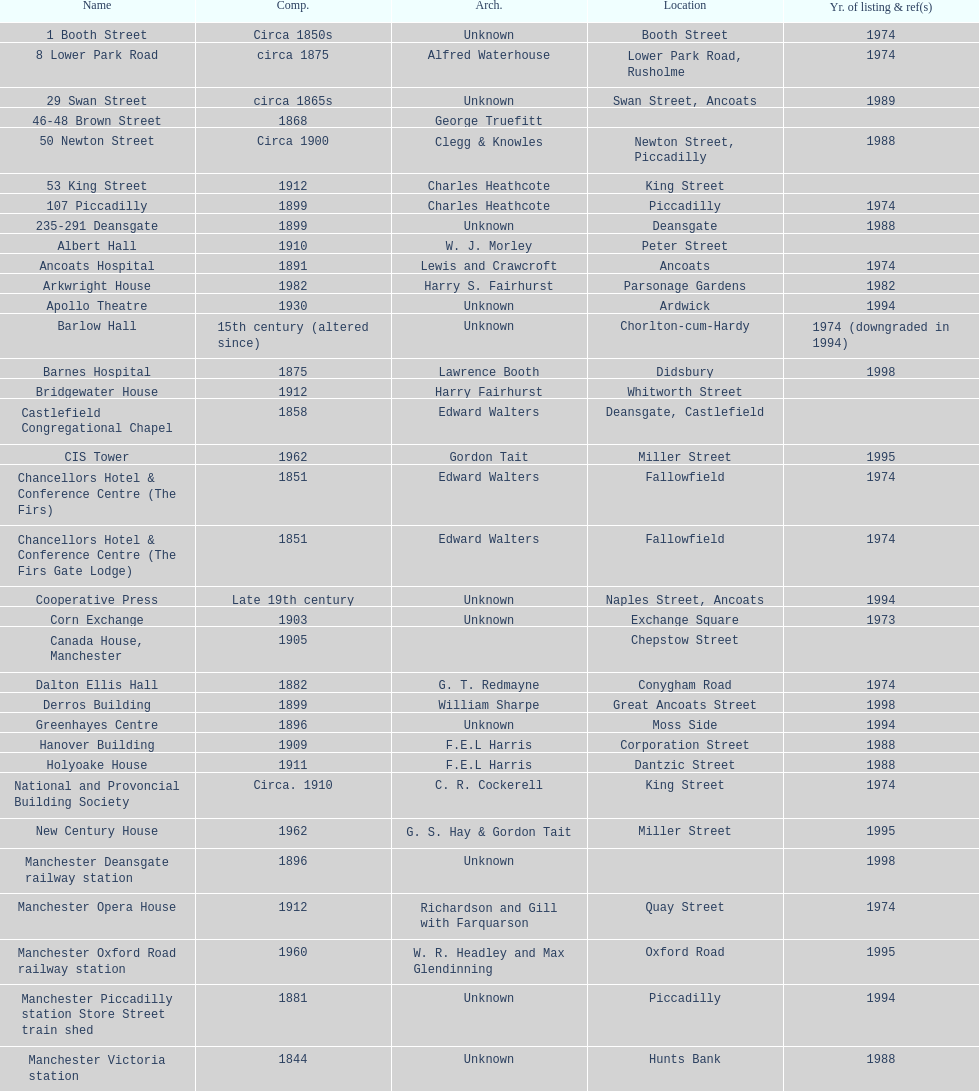How many buildings do not have an image listed? 11. 